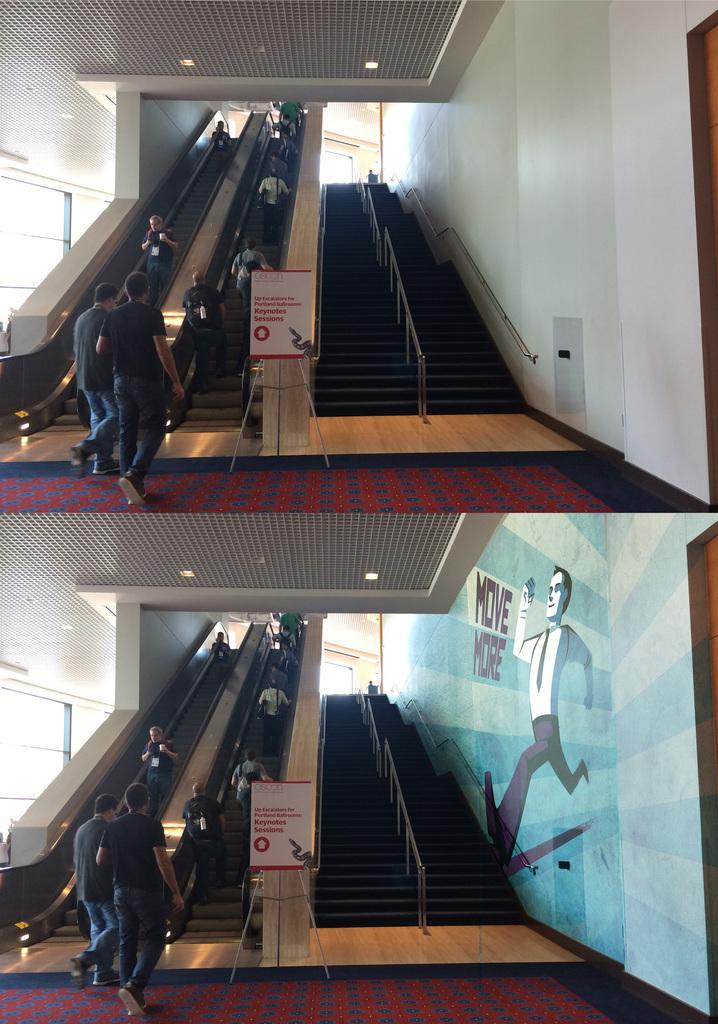Who or what can be seen in the image? There are people in the image. What architectural features are present in the image? There are escalators, boards with stands, lights, steps, railings, and a painting on the wall in the image. What type of drum can be heard playing in the image? There is no drum present in the image, so it is not possible to hear it playing. 